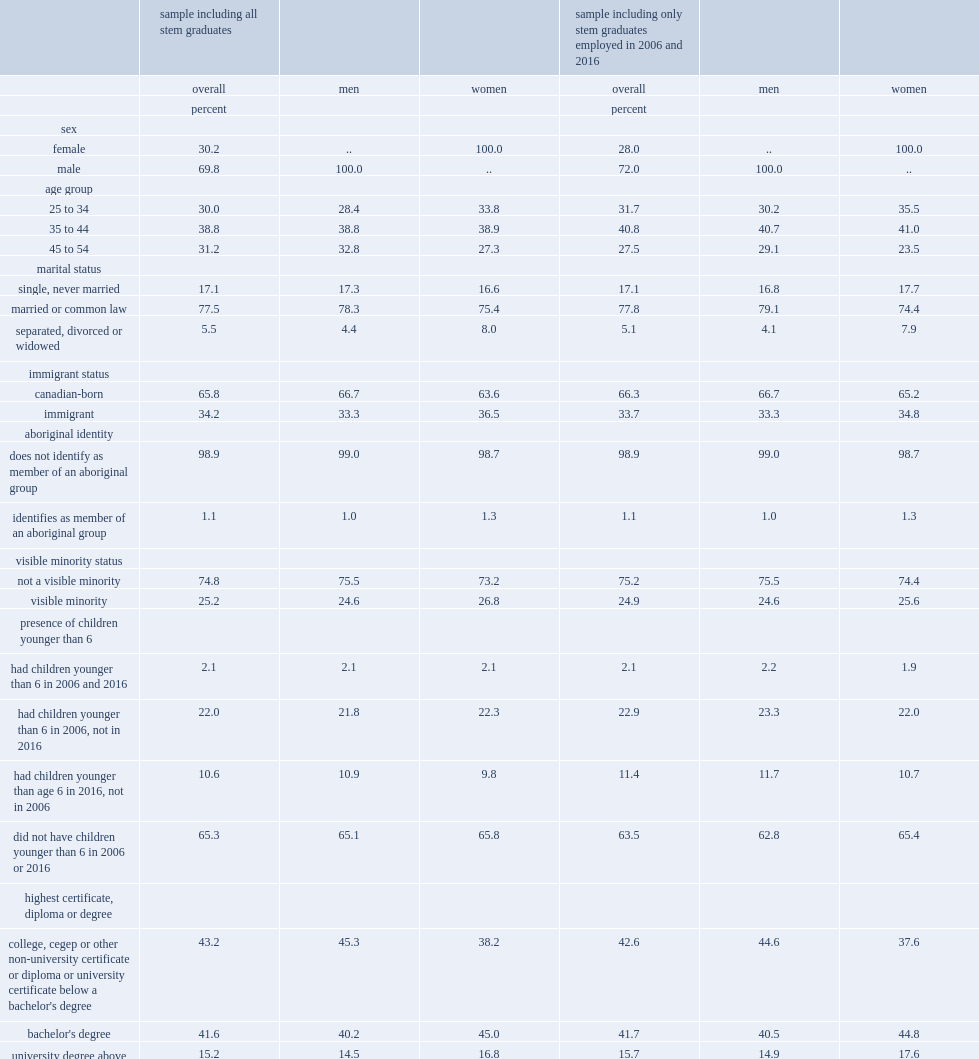What was the percentage of male stem graduates? 69.8. What was the percentage of those married or in a common-law relationship of the sample? 77.5. What was the percentage of those single in 2016? 17.1. What was the percentage of those did not have children younger than 6 in either 2006 or 2016? 65.3. What was the percentage of those who had children younger than 6 in 2006 and 2016? 2.1. What was the percentage of respondents reported being a member of a visible minority group? 25.2. For those with stem credentials,who had a higher proportion of immigrants? Women. What was the percentage of stem graduates identified as a member of an aboriginal group in the longitudinal sample? 1.1. What were the percentages of men and women reported being a member of an aboriginal group respectively? 1.0 1.3. What was the percentage of respondents who achieved their highest level of education outside canada? 20.9. Among those who achieved their highest level of education outside canada,who had a higher proportion,men or women? Women. Who had a higher proportion,graduates reported a college diploma or university certificate below the bachelor's level or those with a bachelor's degree as their highest level of education? College, cegep or other non-university certificate or diploma or university certificate below a bachelor's degree. Who were more likely to have college-level credentials? Men. Which stem field of study had the largest proportion of stem graduates? Engineering and engineering technology. What were the percentages of male and female stem graduates who had studied engineering or engineering technology respectively? 58.2 24.1. Who were more likely to have studied biological, general or integrated sciences,women or men? Women. What was the percentage of stem graduates who had studied mathematics or computer and information sciences? 25.1. 